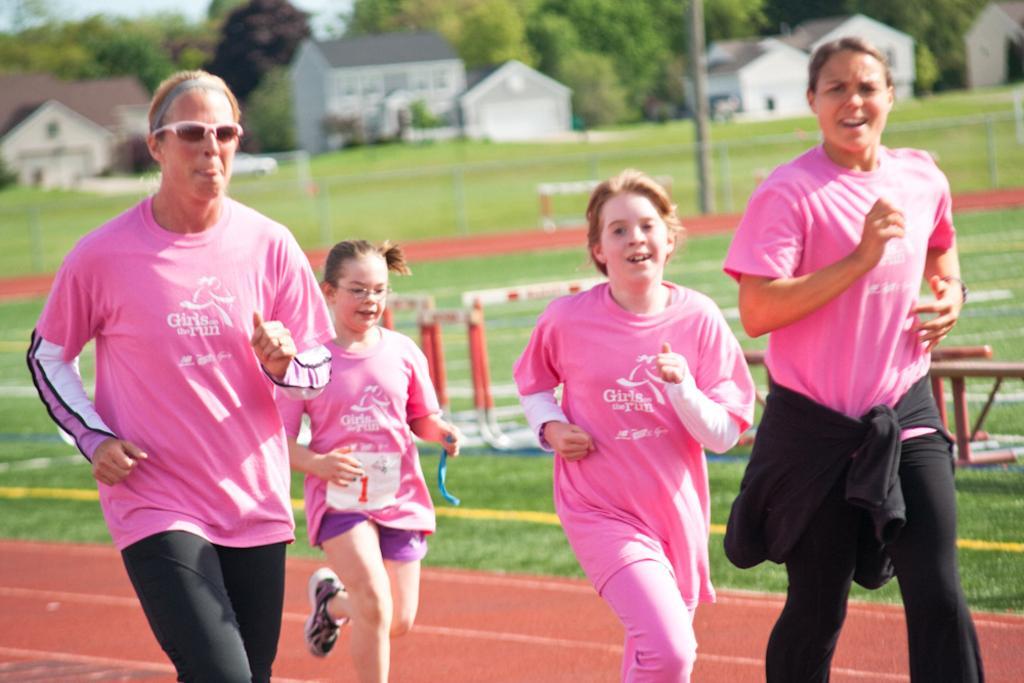How would you summarize this image in a sentence or two? In this image I can see group of people running. In front the person is wearing pink and black color. In the background I can see few poles, houses in white and brown color, trees in green color and the sky is in white color. 